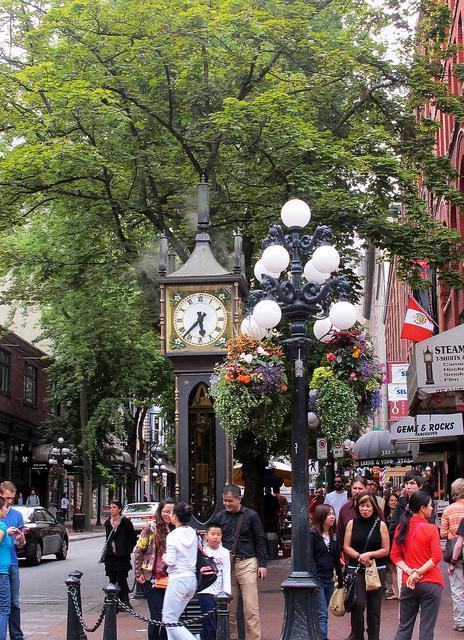How many people are there?
Give a very brief answer. 8. How many people are on their laptop in this image?
Give a very brief answer. 0. 